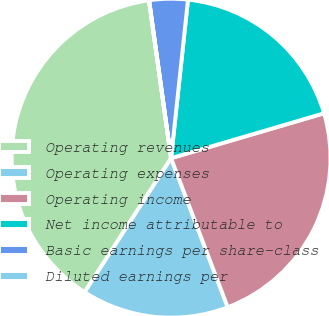<chart> <loc_0><loc_0><loc_500><loc_500><pie_chart><fcel>Operating revenues<fcel>Operating expenses<fcel>Operating income<fcel>Net income attributable to<fcel>Basic earnings per share-class<fcel>Diluted earnings per<nl><fcel>38.66%<fcel>14.9%<fcel>23.76%<fcel>18.76%<fcel>3.89%<fcel>0.02%<nl></chart> 